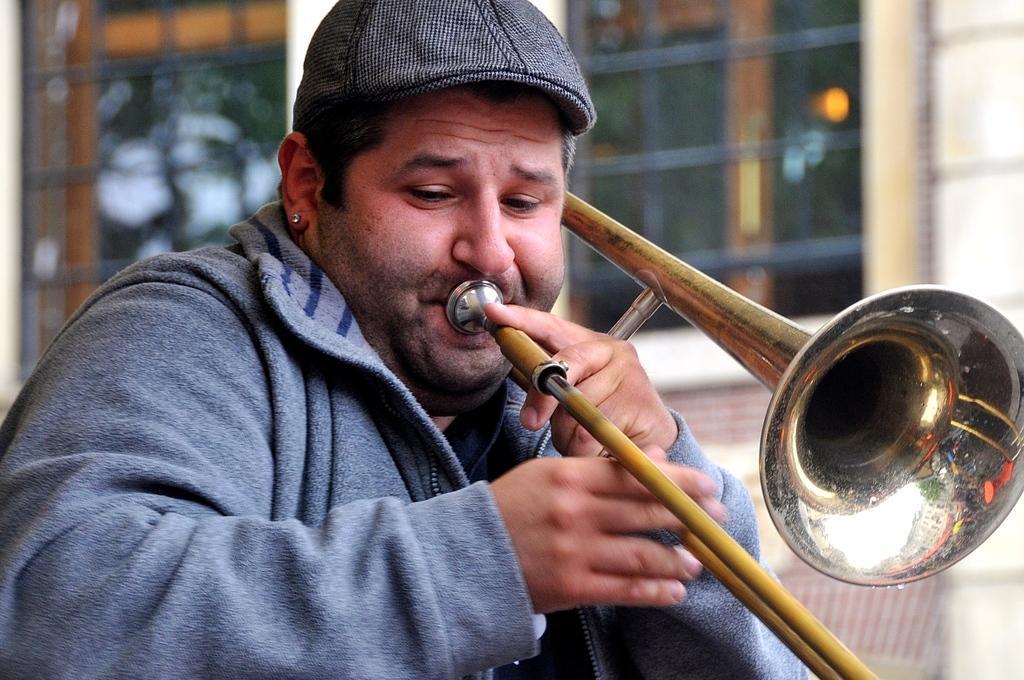Describe this image in one or two sentences. In this image in front there is a person playing a musical instrument. Behind him there are glass windows. 